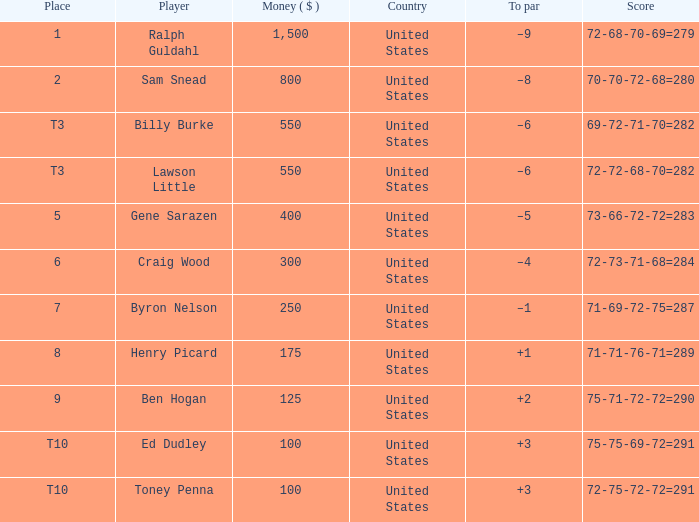Which score has a prize of $400? 73-66-72-72=283. 